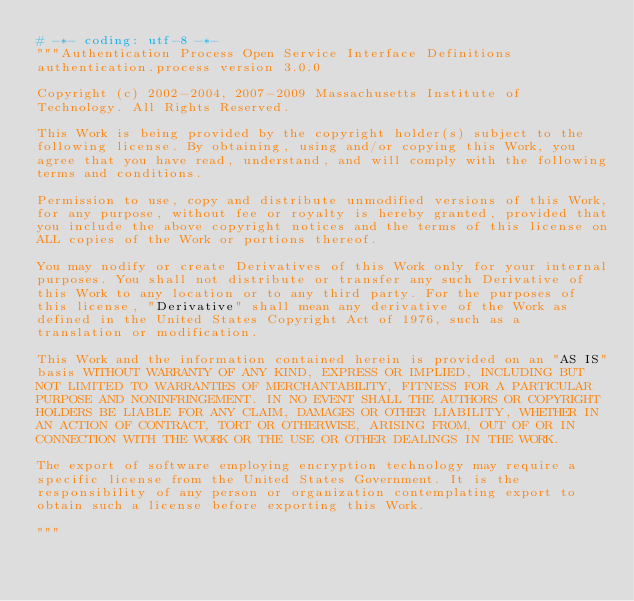<code> <loc_0><loc_0><loc_500><loc_500><_Python_># -*- coding: utf-8 -*-
"""Authentication Process Open Service Interface Definitions
authentication.process version 3.0.0

Copyright (c) 2002-2004, 2007-2009 Massachusetts Institute of
Technology. All Rights Reserved.

This Work is being provided by the copyright holder(s) subject to the
following license. By obtaining, using and/or copying this Work, you
agree that you have read, understand, and will comply with the following
terms and conditions.

Permission to use, copy and distribute unmodified versions of this Work,
for any purpose, without fee or royalty is hereby granted, provided that
you include the above copyright notices and the terms of this license on
ALL copies of the Work or portions thereof.

You may nodify or create Derivatives of this Work only for your internal
purposes. You shall not distribute or transfer any such Derivative of
this Work to any location or to any third party. For the purposes of
this license, "Derivative" shall mean any derivative of the Work as
defined in the United States Copyright Act of 1976, such as a
translation or modification.

This Work and the information contained herein is provided on an "AS IS"
basis WITHOUT WARRANTY OF ANY KIND, EXPRESS OR IMPLIED, INCLUDING BUT
NOT LIMITED TO WARRANTIES OF MERCHANTABILITY, FITNESS FOR A PARTICULAR
PURPOSE AND NONINFRINGEMENT. IN NO EVENT SHALL THE AUTHORS OR COPYRIGHT
HOLDERS BE LIABLE FOR ANY CLAIM, DAMAGES OR OTHER LIABILITY, WHETHER IN
AN ACTION OF CONTRACT, TORT OR OTHERWISE, ARISING FROM, OUT OF OR IN
CONNECTION WITH THE WORK OR THE USE OR OTHER DEALINGS IN THE WORK.

The export of software employing encryption technology may require a
specific license from the United States Government. It is the
responsibility of any person or organization contemplating export to
obtain such a license before exporting this Work.

"""
</code> 